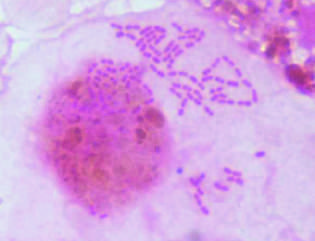does gram stain preparation of a bronchoalveolar lavage specimen show gram-negative intracellular rods typical of members of enterobacteriaceae such as klebsiella pneumoniae or escherichia coli?
Answer the question using a single word or phrase. Yes 